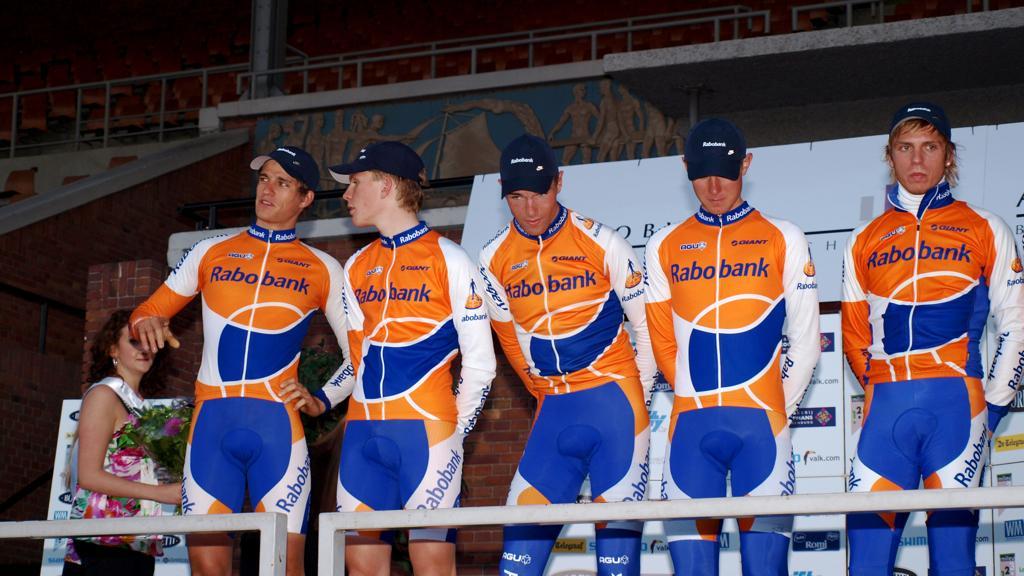Could you give a brief overview of what you see in this image? In this image we can see people are standing and there is a woman holding a bouquet. Here we can see railings, chairs, wall, pillar, and banners. 